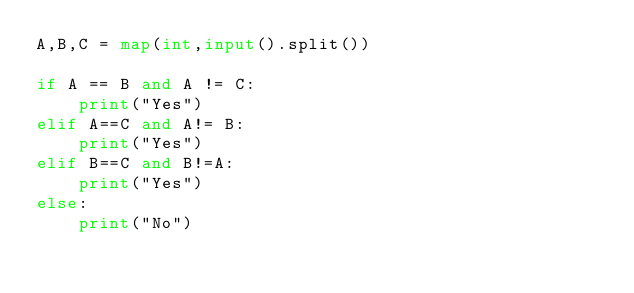Convert code to text. <code><loc_0><loc_0><loc_500><loc_500><_Python_>A,B,C = map(int,input().split())

if A == B and A != C:
    print("Yes")
elif A==C and A!= B:
    print("Yes")
elif B==C and B!=A:
    print("Yes")
else:
    print("No")
</code> 